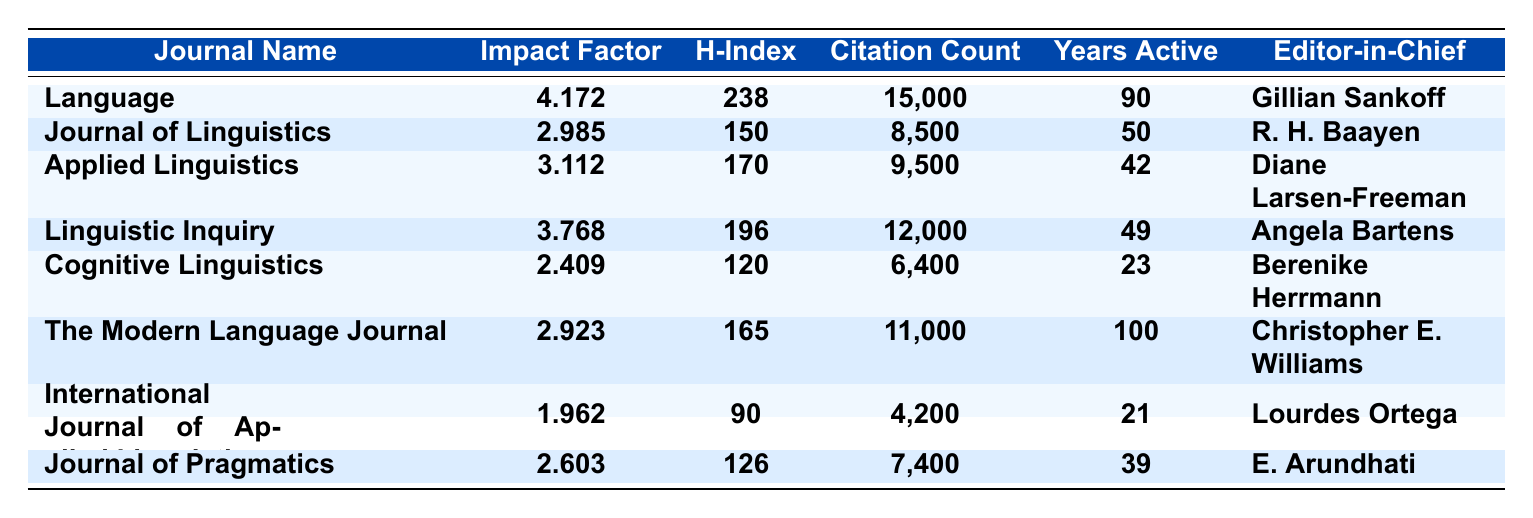What is the impact factor of the journal "Language"? The table lists "Language" as having an impact factor of 4.172.
Answer: 4.172 Which journal has the highest h-index? The table shows that "Language" has the highest h-index of 238 compared to the other journals.
Answer: Language How many years has "The Modern Language Journal" been active? According to the table, "The Modern Language Journal" has been active for 100 years.
Answer: 100 What is the total citation count of "Linguistic Inquiry" and "Journal of Pragmatics"? The citation count for "Linguistic Inquiry" is 12,000 and for "Journal of Pragmatics" is 7,400. Adding these gives 12,000 + 7,400 = 19,400.
Answer: 19,400 Does "Cognitive Linguistics" have an impact factor greater than 2.5? The table indicates that "Cognitive Linguistics" has an impact factor of 2.409, which is less than 2.5.
Answer: No What is the average impact factor of the first three journals listed? The impact factors of the first three journals are 4.172, 2.985, and 3.112. To find the average, sum these values: 4.172 + 2.985 + 3.112 = 10.269, then divide by 3, giving an average of 10.269 / 3 = 3.423.
Answer: 3.423 Which editor-in-chief oversees "Applied Linguistics"? The table states that "Applied Linguistics" is overseen by Diane Larsen-Freeman.
Answer: Diane Larsen-Freeman Is the citation count of "International Journal of Applied Linguistics" more than 4,500? The citation count for "International Journal of Applied Linguistics" is 4,200, which is less than 4,500.
Answer: No What is the difference in h-index between "Journal of Linguistics" and "Cognitive Linguistics"? The h-index for "Journal of Linguistics" is 150 and for "Cognitive Linguistics" is 120. The difference is 150 - 120 = 30.
Answer: 30 Which journal has been active for the shortest duration and what is that duration? The table shows that "International Journal of Applied Linguistics" has been active for 21 years, the shortest duration compared to the other journals.
Answer: 21 What is the median citation count of the journals listed in the table? The citation counts from lowest to highest are: 4,200; 6,400; 7,400; 8,500; 9,500; 11,000; 12,000; 15,000. There are 8 data points, the median will be the average of the 4th and 5th values: (8,500 + 9,500) / 2 = 9,000.
Answer: 9,000 